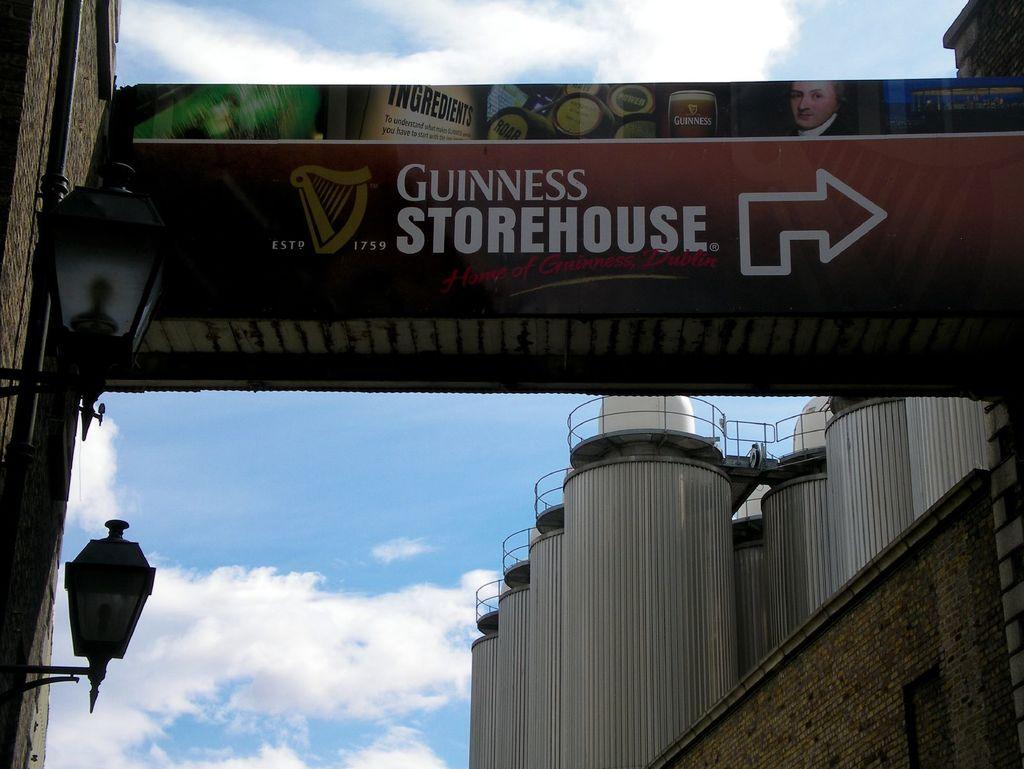<image>
Render a clear and concise summary of the photo. A sign directs you to the Guinness Storehouse. 